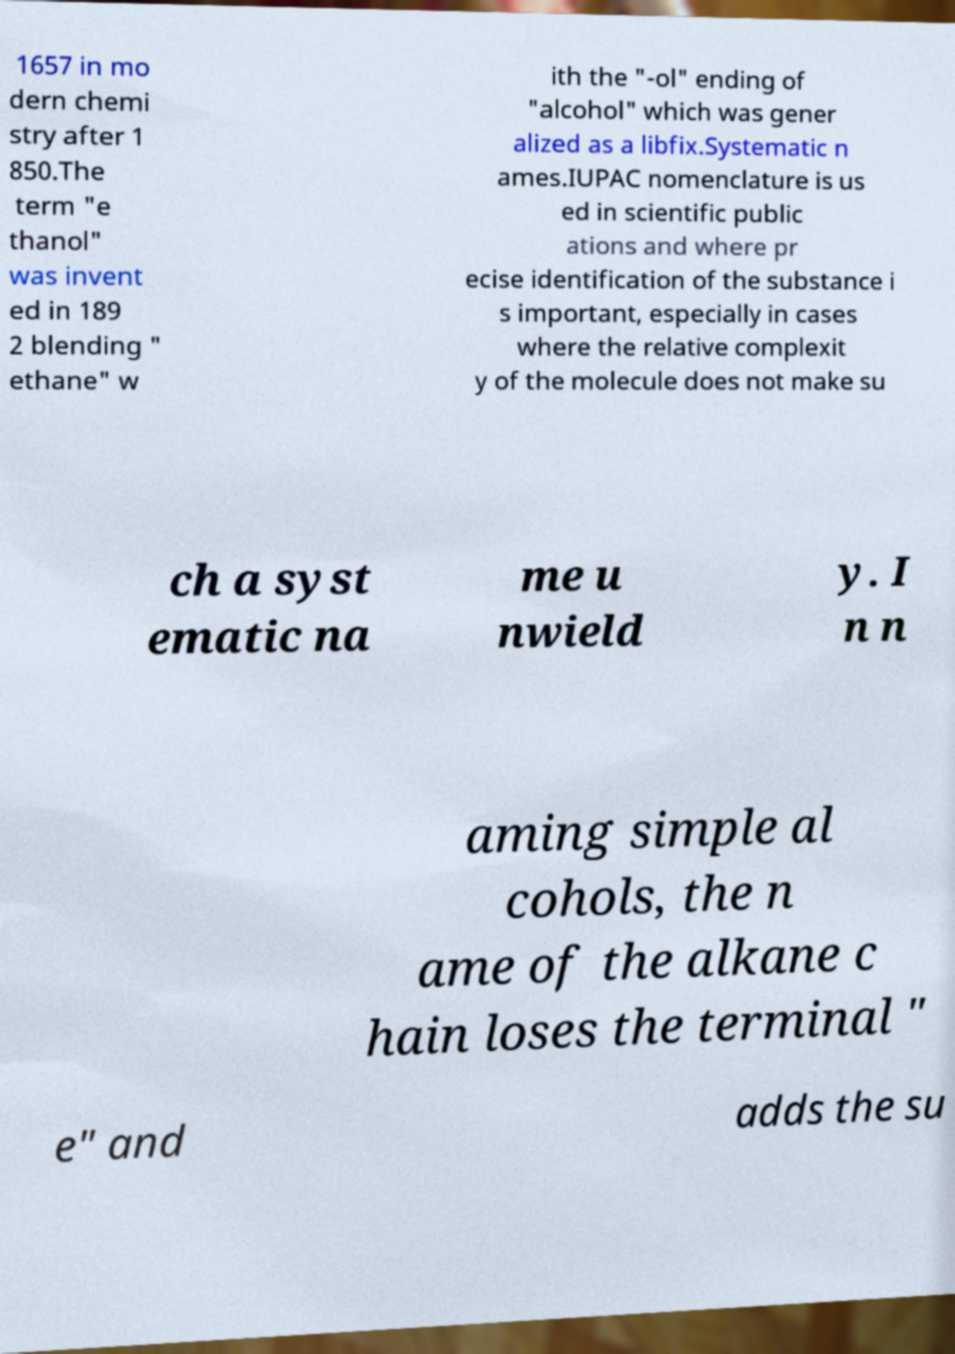There's text embedded in this image that I need extracted. Can you transcribe it verbatim? 1657 in mo dern chemi stry after 1 850.The term "e thanol" was invent ed in 189 2 blending " ethane" w ith the "-ol" ending of "alcohol" which was gener alized as a libfix.Systematic n ames.IUPAC nomenclature is us ed in scientific public ations and where pr ecise identification of the substance i s important, especially in cases where the relative complexit y of the molecule does not make su ch a syst ematic na me u nwield y. I n n aming simple al cohols, the n ame of the alkane c hain loses the terminal " e" and adds the su 